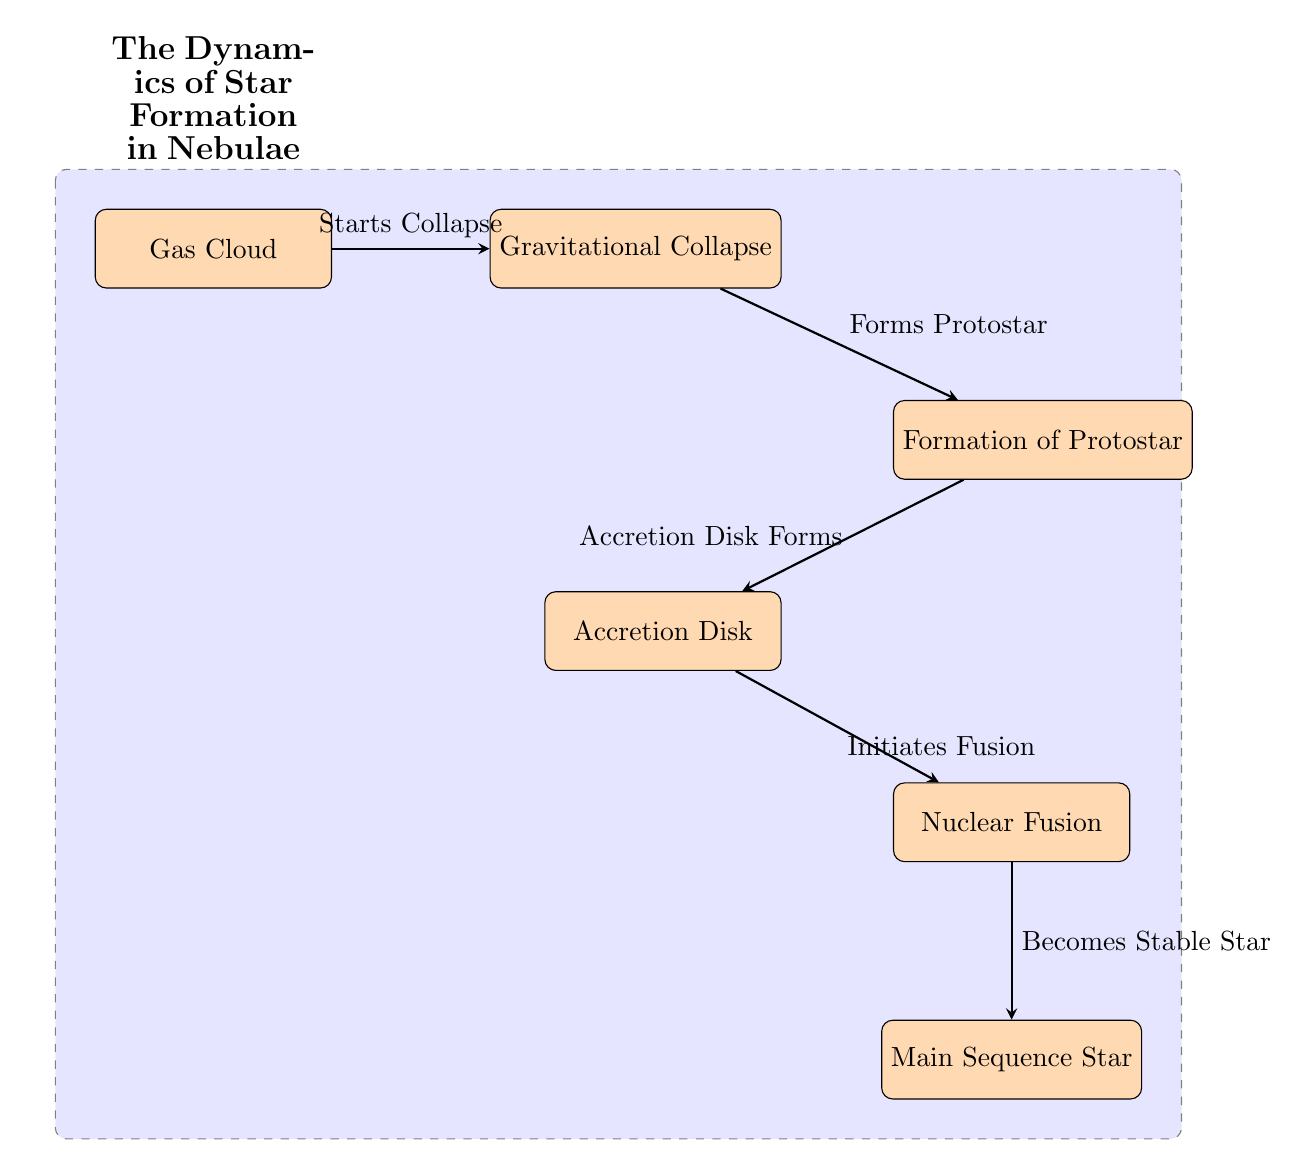What is the first stage in the star formation process? The diagram shows "Gas Cloud" as the first node. This is the starting point in the process of star formation.
Answer: Gas Cloud How many main processes are illustrated in the diagram? The diagram includes five distinct main processes (nodes): Gas Cloud, Gravitational Collapse, Formation of Protostar, Accretion Disk, Nuclear Fusion, and Main Sequence Star. Therefore, the total is six.
Answer: Six What happens after the "Gravitational Collapse"? According to the arrows connecting the nodes, after "Gravitational Collapse", a "Protostar" is formed. This indicates the next stage in the sequence.
Answer: Forms Protostar What initiates "Nuclear Fusion" in the diagram? The diagram shows that "Nuclear Fusion" begins when the "Accretion Disk" forms and is connected by an arrow leading to it. This implies that the formation of the Accretion Disk is critical for initiating Nuclear Fusion.
Answer: Accretion Disk Forms What is the final outcome depicted in the diagram? The final node at the bottom of the diagram is "Main Sequence Star." This indicates that the process culminates in the formation of a stable star after the previous stages of protostar formation and nuclear fusion.
Answer: Main Sequence Star 